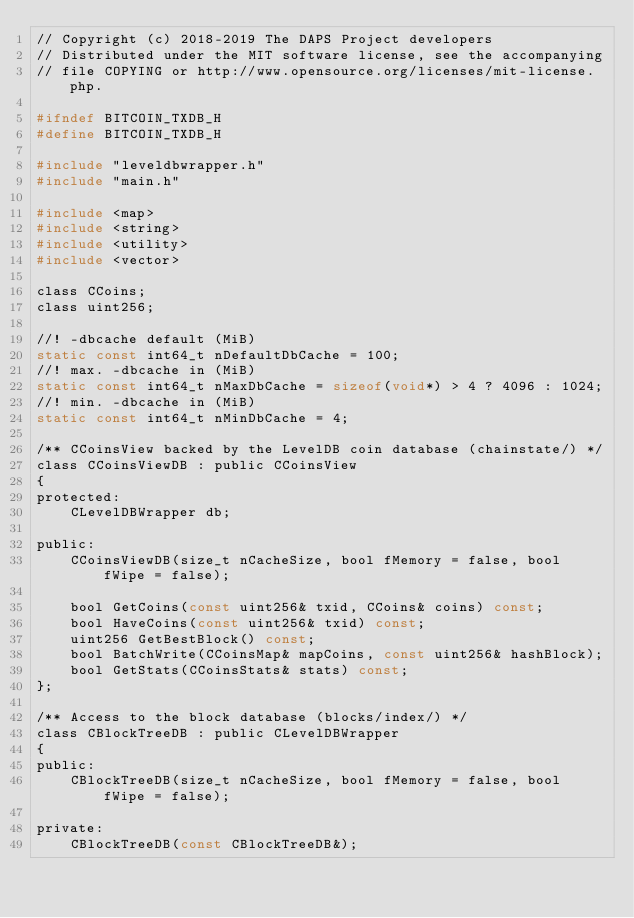<code> <loc_0><loc_0><loc_500><loc_500><_C_>// Copyright (c) 2018-2019 The DAPS Project developers
// Distributed under the MIT software license, see the accompanying
// file COPYING or http://www.opensource.org/licenses/mit-license.php.

#ifndef BITCOIN_TXDB_H
#define BITCOIN_TXDB_H

#include "leveldbwrapper.h"
#include "main.h"

#include <map>
#include <string>
#include <utility>
#include <vector>

class CCoins;
class uint256;

//! -dbcache default (MiB)
static const int64_t nDefaultDbCache = 100;
//! max. -dbcache in (MiB)
static const int64_t nMaxDbCache = sizeof(void*) > 4 ? 4096 : 1024;
//! min. -dbcache in (MiB)
static const int64_t nMinDbCache = 4;

/** CCoinsView backed by the LevelDB coin database (chainstate/) */
class CCoinsViewDB : public CCoinsView
{
protected:
    CLevelDBWrapper db;

public:
    CCoinsViewDB(size_t nCacheSize, bool fMemory = false, bool fWipe = false);

    bool GetCoins(const uint256& txid, CCoins& coins) const;
    bool HaveCoins(const uint256& txid) const;
    uint256 GetBestBlock() const;
    bool BatchWrite(CCoinsMap& mapCoins, const uint256& hashBlock);
    bool GetStats(CCoinsStats& stats) const;
};

/** Access to the block database (blocks/index/) */
class CBlockTreeDB : public CLevelDBWrapper
{
public:
    CBlockTreeDB(size_t nCacheSize, bool fMemory = false, bool fWipe = false);

private:
    CBlockTreeDB(const CBlockTreeDB&);</code> 